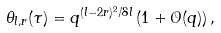Convert formula to latex. <formula><loc_0><loc_0><loc_500><loc_500>\theta _ { l , r } ( \tau ) = q ^ { ( l - 2 r ) ^ { 2 } / 8 l } \left ( 1 + \mathcal { O } ( q ) \right ) ,</formula> 